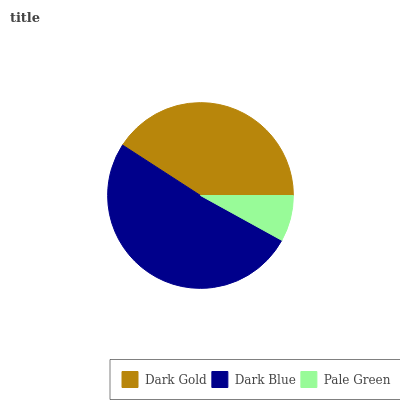Is Pale Green the minimum?
Answer yes or no. Yes. Is Dark Blue the maximum?
Answer yes or no. Yes. Is Dark Blue the minimum?
Answer yes or no. No. Is Pale Green the maximum?
Answer yes or no. No. Is Dark Blue greater than Pale Green?
Answer yes or no. Yes. Is Pale Green less than Dark Blue?
Answer yes or no. Yes. Is Pale Green greater than Dark Blue?
Answer yes or no. No. Is Dark Blue less than Pale Green?
Answer yes or no. No. Is Dark Gold the high median?
Answer yes or no. Yes. Is Dark Gold the low median?
Answer yes or no. Yes. Is Dark Blue the high median?
Answer yes or no. No. Is Dark Blue the low median?
Answer yes or no. No. 